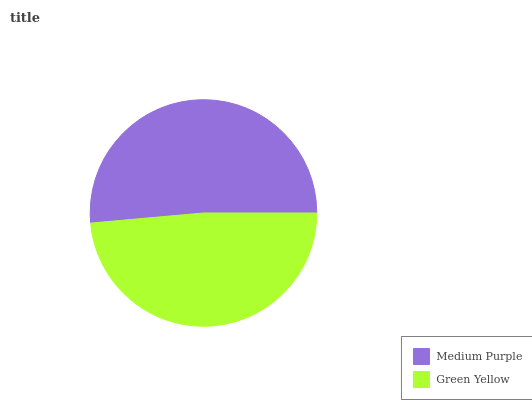Is Green Yellow the minimum?
Answer yes or no. Yes. Is Medium Purple the maximum?
Answer yes or no. Yes. Is Green Yellow the maximum?
Answer yes or no. No. Is Medium Purple greater than Green Yellow?
Answer yes or no. Yes. Is Green Yellow less than Medium Purple?
Answer yes or no. Yes. Is Green Yellow greater than Medium Purple?
Answer yes or no. No. Is Medium Purple less than Green Yellow?
Answer yes or no. No. Is Medium Purple the high median?
Answer yes or no. Yes. Is Green Yellow the low median?
Answer yes or no. Yes. Is Green Yellow the high median?
Answer yes or no. No. Is Medium Purple the low median?
Answer yes or no. No. 